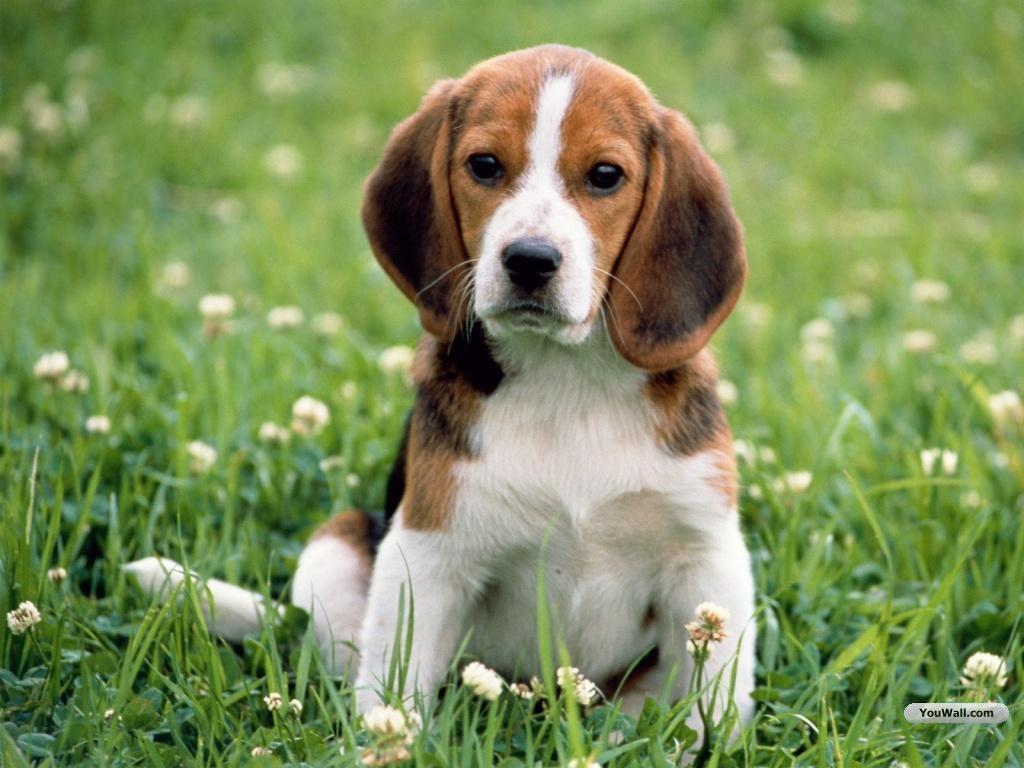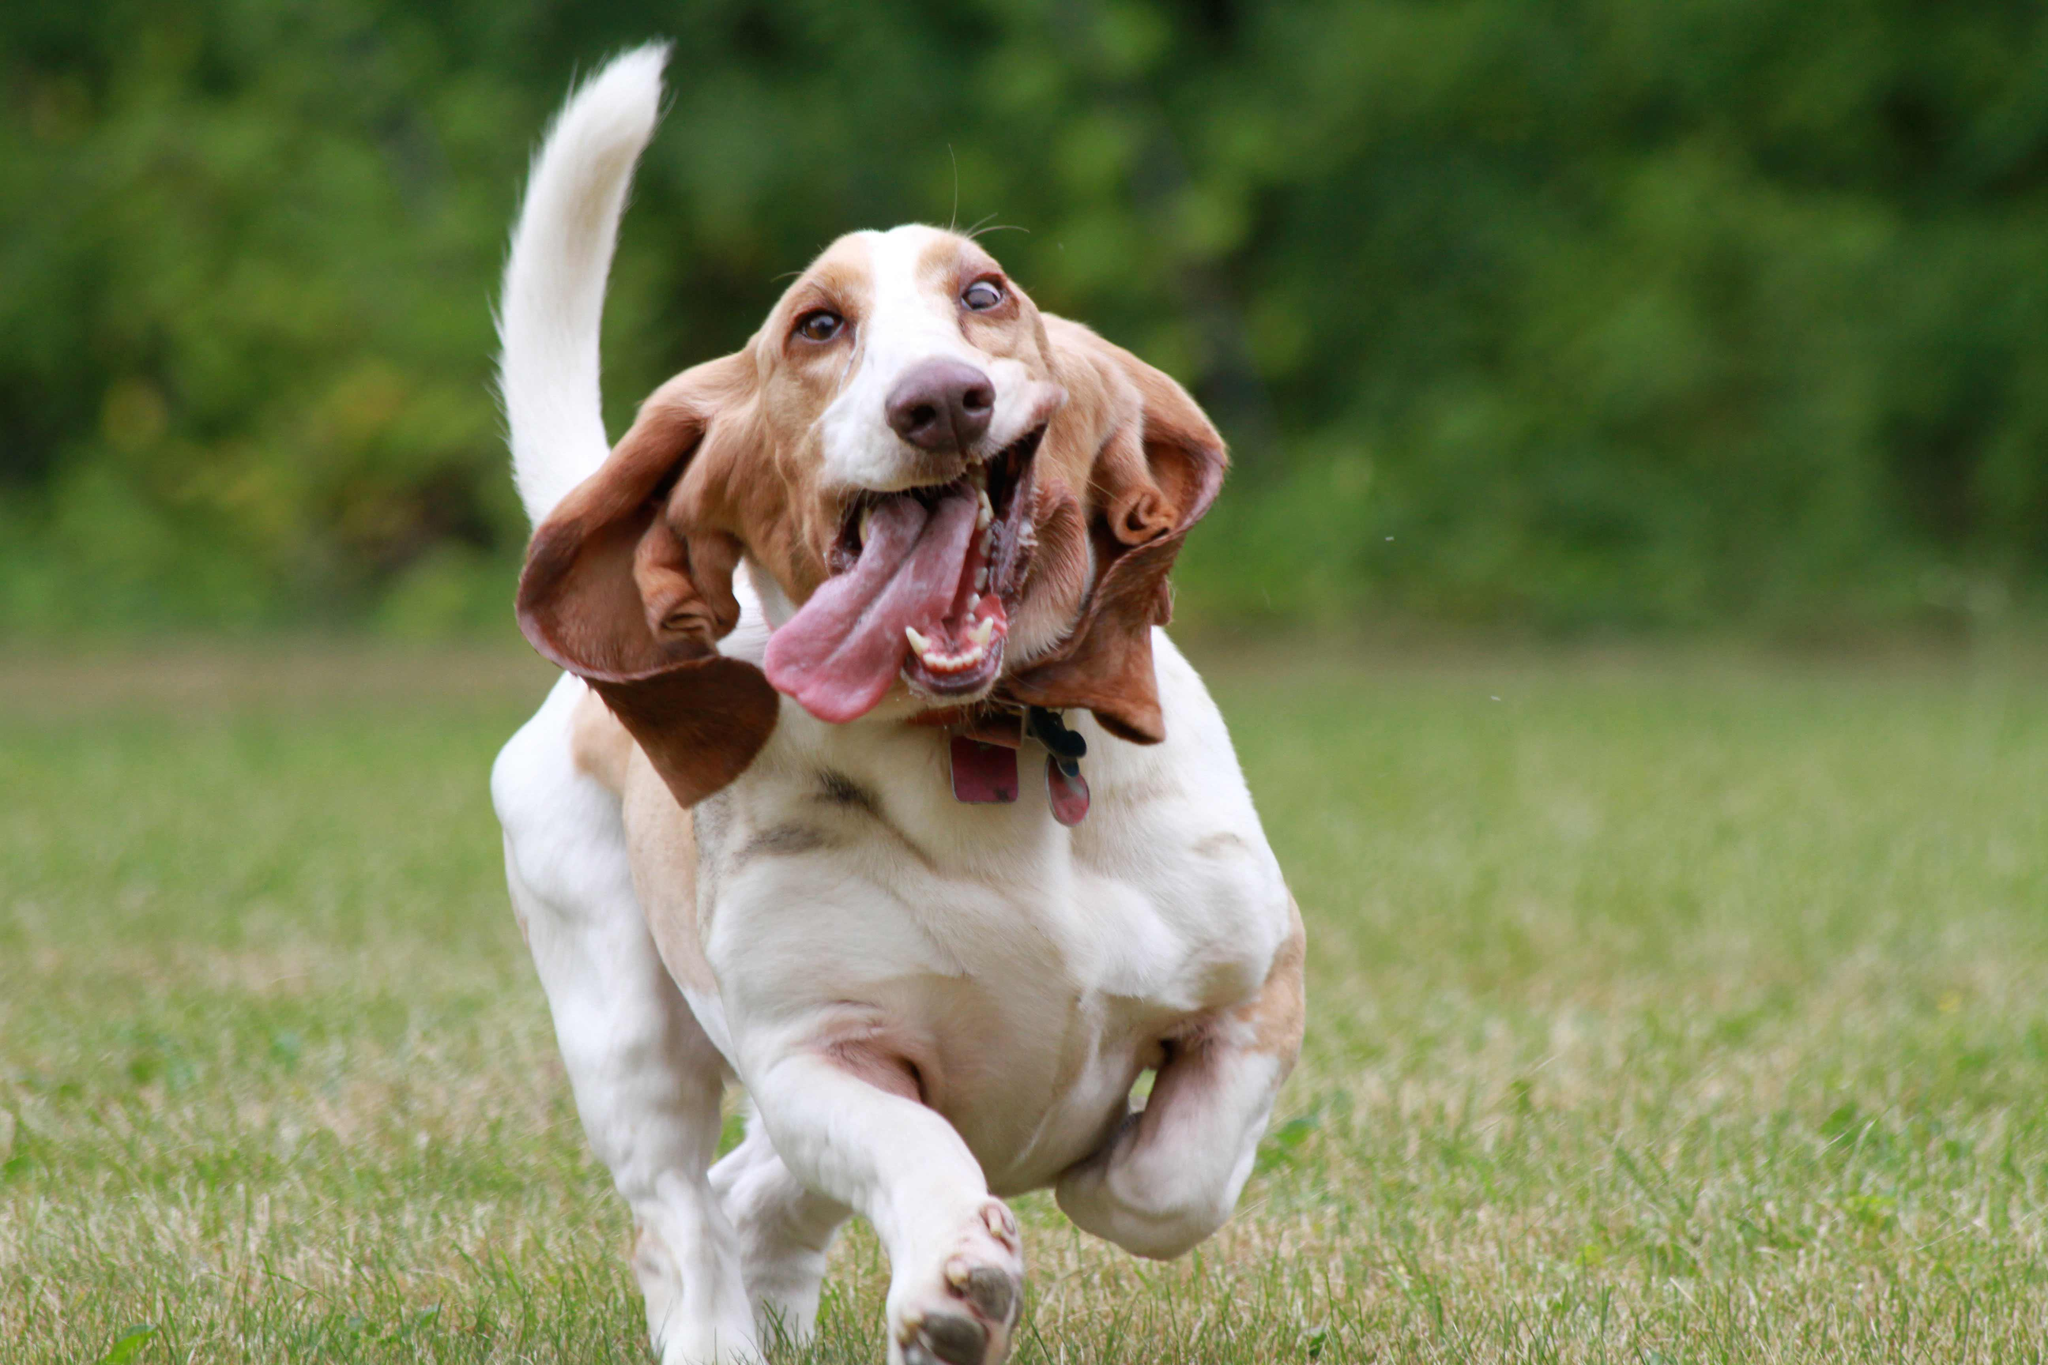The first image is the image on the left, the second image is the image on the right. Considering the images on both sides, is "A floppy eared dog is moving forward across the grass in one image." valid? Answer yes or no. Yes. The first image is the image on the left, the second image is the image on the right. For the images shown, is this caption "the dog appears to be moving in one of the images" true? Answer yes or no. Yes. 